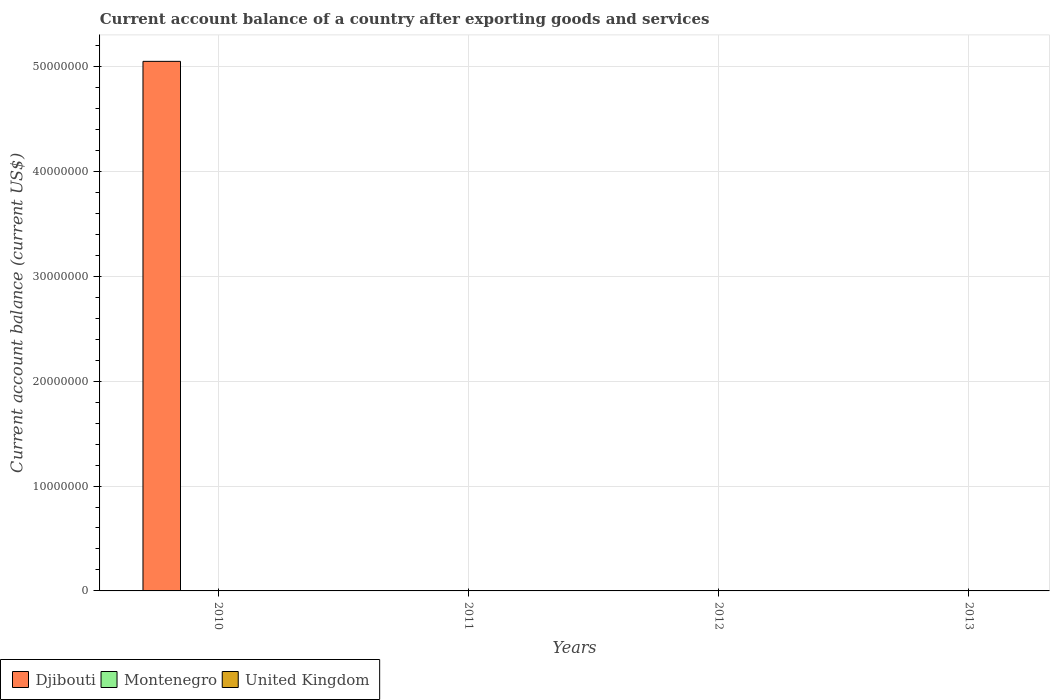How many different coloured bars are there?
Your response must be concise. 1. Are the number of bars per tick equal to the number of legend labels?
Ensure brevity in your answer.  No. How many bars are there on the 1st tick from the right?
Give a very brief answer. 0. What is the label of the 4th group of bars from the left?
Give a very brief answer. 2013. What is the account balance in Montenegro in 2012?
Offer a terse response. 0. What is the total account balance in Djibouti in the graph?
Your answer should be very brief. 5.05e+07. What is the difference between the highest and the lowest account balance in Djibouti?
Your answer should be very brief. 5.05e+07. Is it the case that in every year, the sum of the account balance in Djibouti and account balance in Montenegro is greater than the account balance in United Kingdom?
Provide a succinct answer. No. Does the graph contain grids?
Offer a terse response. Yes. How many legend labels are there?
Give a very brief answer. 3. How are the legend labels stacked?
Give a very brief answer. Horizontal. What is the title of the graph?
Provide a succinct answer. Current account balance of a country after exporting goods and services. Does "Belgium" appear as one of the legend labels in the graph?
Ensure brevity in your answer.  No. What is the label or title of the Y-axis?
Give a very brief answer. Current account balance (current US$). What is the Current account balance (current US$) of Djibouti in 2010?
Provide a short and direct response. 5.05e+07. What is the Current account balance (current US$) of Montenegro in 2011?
Your answer should be very brief. 0. What is the Current account balance (current US$) of United Kingdom in 2011?
Provide a succinct answer. 0. What is the Current account balance (current US$) of Djibouti in 2012?
Your response must be concise. 0. What is the Current account balance (current US$) in Montenegro in 2012?
Your answer should be very brief. 0. What is the Current account balance (current US$) of Montenegro in 2013?
Offer a very short reply. 0. Across all years, what is the maximum Current account balance (current US$) in Djibouti?
Keep it short and to the point. 5.05e+07. Across all years, what is the minimum Current account balance (current US$) in Djibouti?
Make the answer very short. 0. What is the total Current account balance (current US$) in Djibouti in the graph?
Your response must be concise. 5.05e+07. What is the total Current account balance (current US$) in Montenegro in the graph?
Your response must be concise. 0. What is the total Current account balance (current US$) of United Kingdom in the graph?
Provide a short and direct response. 0. What is the average Current account balance (current US$) in Djibouti per year?
Provide a short and direct response. 1.26e+07. What is the average Current account balance (current US$) of Montenegro per year?
Ensure brevity in your answer.  0. What is the average Current account balance (current US$) in United Kingdom per year?
Ensure brevity in your answer.  0. What is the difference between the highest and the lowest Current account balance (current US$) of Djibouti?
Provide a short and direct response. 5.05e+07. 